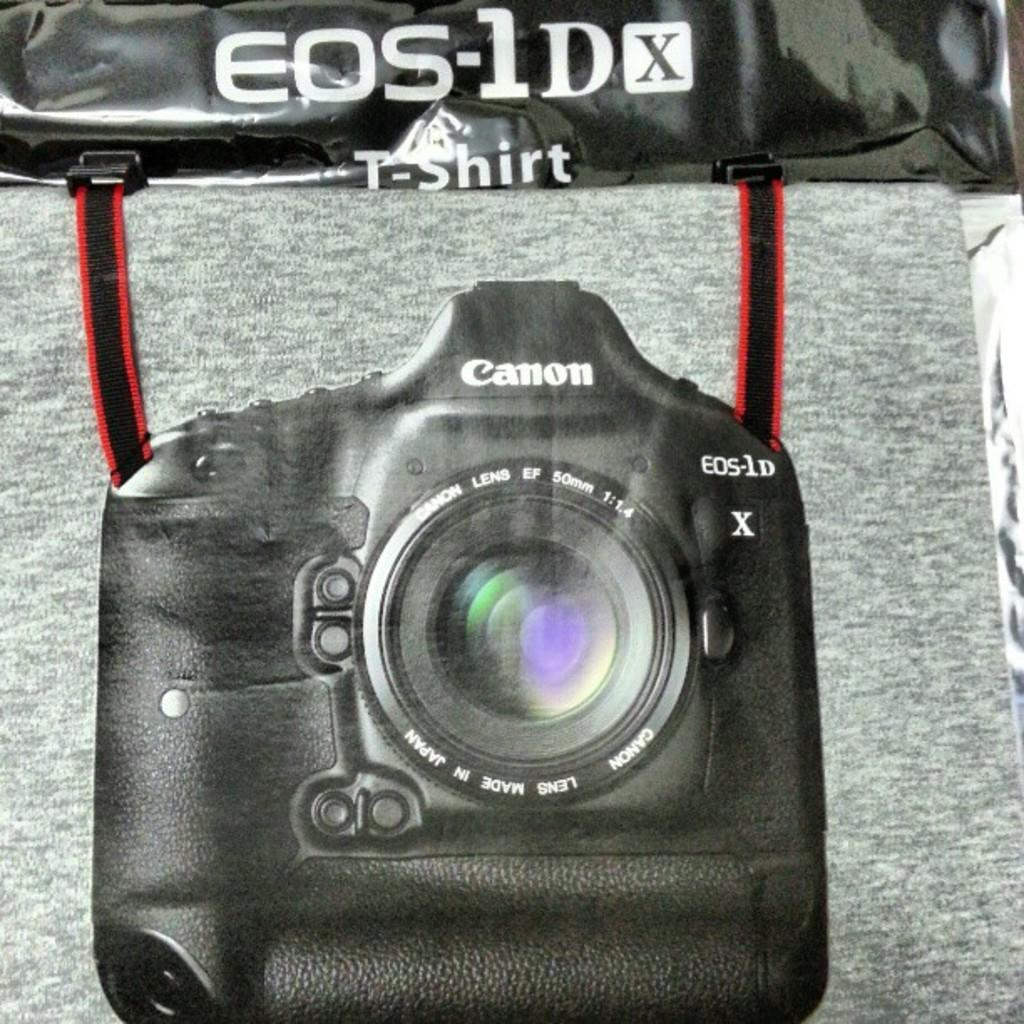What is the main object in the image? There is a camera in the image. Can you describe any additional details about the camera? Unfortunately, the provided facts do not mention any additional details about the camera. What is written or visible on the top of the image? There is some text visible on the top of the image. What type of bun is being used to hold the camera in the image? There is no bun present in the image; the camera is not being held by any object. What scientific principles are being demonstrated in the image? The provided facts do not mention any scientific principles being demonstrated in the image. 